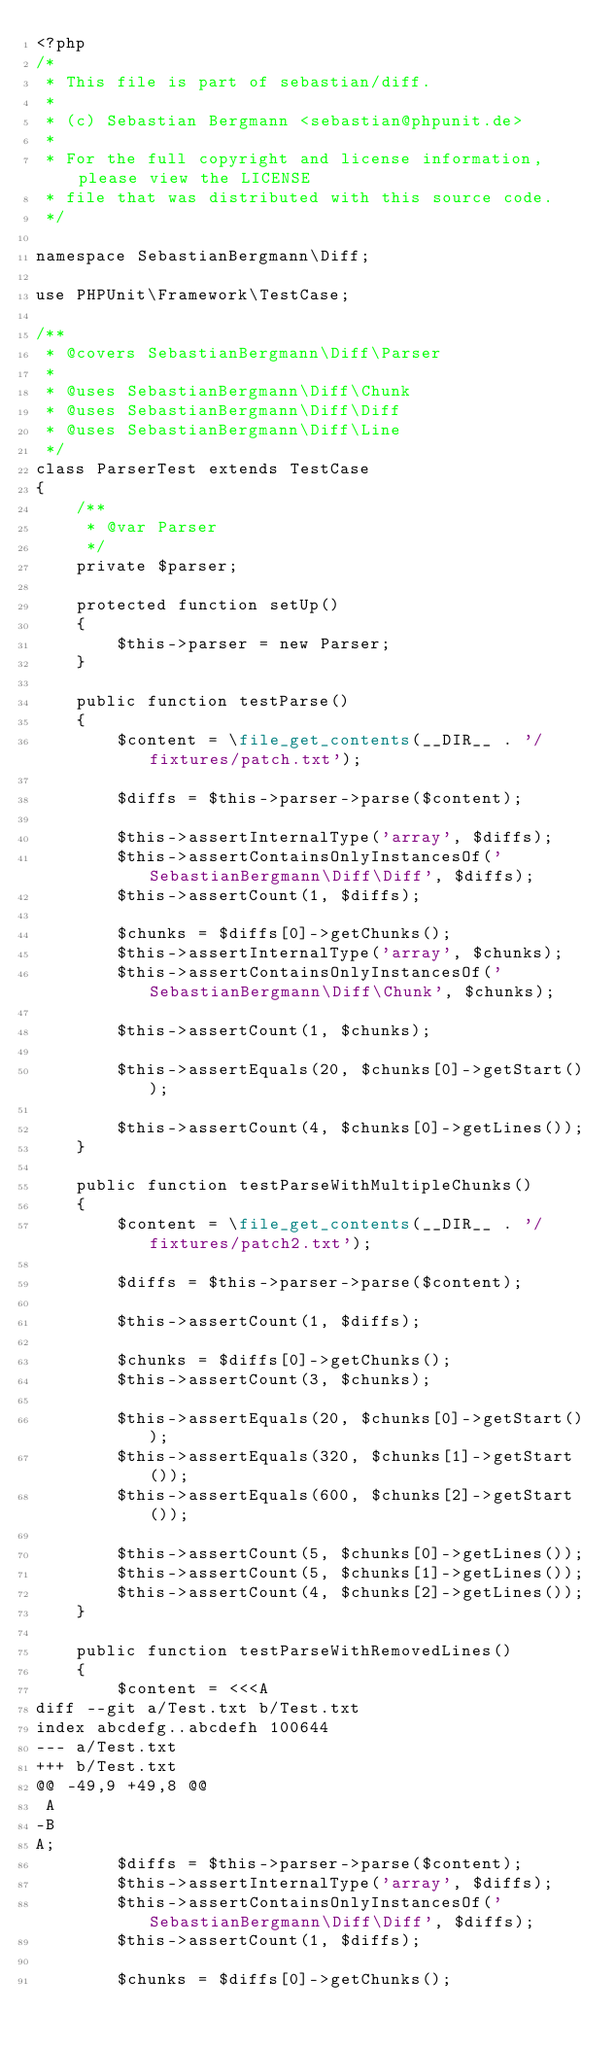Convert code to text. <code><loc_0><loc_0><loc_500><loc_500><_PHP_><?php
/*
 * This file is part of sebastian/diff.
 *
 * (c) Sebastian Bergmann <sebastian@phpunit.de>
 *
 * For the full copyright and license information, please view the LICENSE
 * file that was distributed with this source code.
 */

namespace SebastianBergmann\Diff;

use PHPUnit\Framework\TestCase;

/**
 * @covers SebastianBergmann\Diff\Parser
 *
 * @uses SebastianBergmann\Diff\Chunk
 * @uses SebastianBergmann\Diff\Diff
 * @uses SebastianBergmann\Diff\Line
 */
class ParserTest extends TestCase
{
    /**
     * @var Parser
     */
    private $parser;

    protected function setUp()
    {
        $this->parser = new Parser;
    }

    public function testParse()
    {
        $content = \file_get_contents(__DIR__ . '/fixtures/patch.txt');

        $diffs = $this->parser->parse($content);

        $this->assertInternalType('array', $diffs);
        $this->assertContainsOnlyInstancesOf('SebastianBergmann\Diff\Diff', $diffs);
        $this->assertCount(1, $diffs);

        $chunks = $diffs[0]->getChunks();
        $this->assertInternalType('array', $chunks);
        $this->assertContainsOnlyInstancesOf('SebastianBergmann\Diff\Chunk', $chunks);

        $this->assertCount(1, $chunks);

        $this->assertEquals(20, $chunks[0]->getStart());

        $this->assertCount(4, $chunks[0]->getLines());
    }

    public function testParseWithMultipleChunks()
    {
        $content = \file_get_contents(__DIR__ . '/fixtures/patch2.txt');

        $diffs = $this->parser->parse($content);

        $this->assertCount(1, $diffs);

        $chunks = $diffs[0]->getChunks();
        $this->assertCount(3, $chunks);

        $this->assertEquals(20, $chunks[0]->getStart());
        $this->assertEquals(320, $chunks[1]->getStart());
        $this->assertEquals(600, $chunks[2]->getStart());

        $this->assertCount(5, $chunks[0]->getLines());
        $this->assertCount(5, $chunks[1]->getLines());
        $this->assertCount(4, $chunks[2]->getLines());
    }

    public function testParseWithRemovedLines()
    {
        $content = <<<A
diff --git a/Test.txt b/Test.txt
index abcdefg..abcdefh 100644
--- a/Test.txt
+++ b/Test.txt
@@ -49,9 +49,8 @@
 A
-B
A;
        $diffs = $this->parser->parse($content);
        $this->assertInternalType('array', $diffs);
        $this->assertContainsOnlyInstancesOf('SebastianBergmann\Diff\Diff', $diffs);
        $this->assertCount(1, $diffs);

        $chunks = $diffs[0]->getChunks();
</code> 